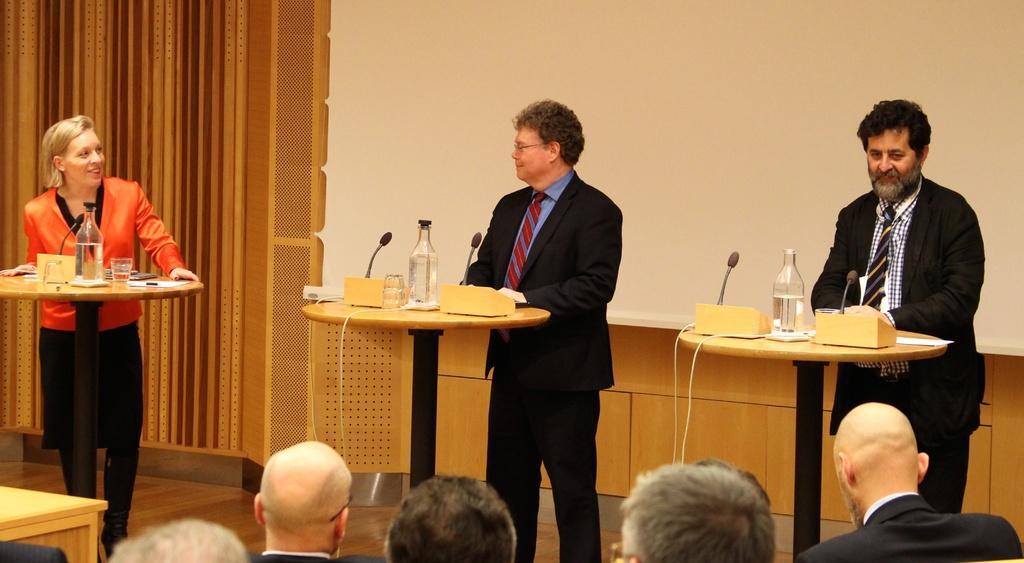Please provide a concise description of this image. There are three members standing near the tables on which a water bottles, microphone was placed. One of them was woman, standing on the left side. Two of them were men. And there are some people sitting and watching them. In the background there is a projector display screen and a wall. 